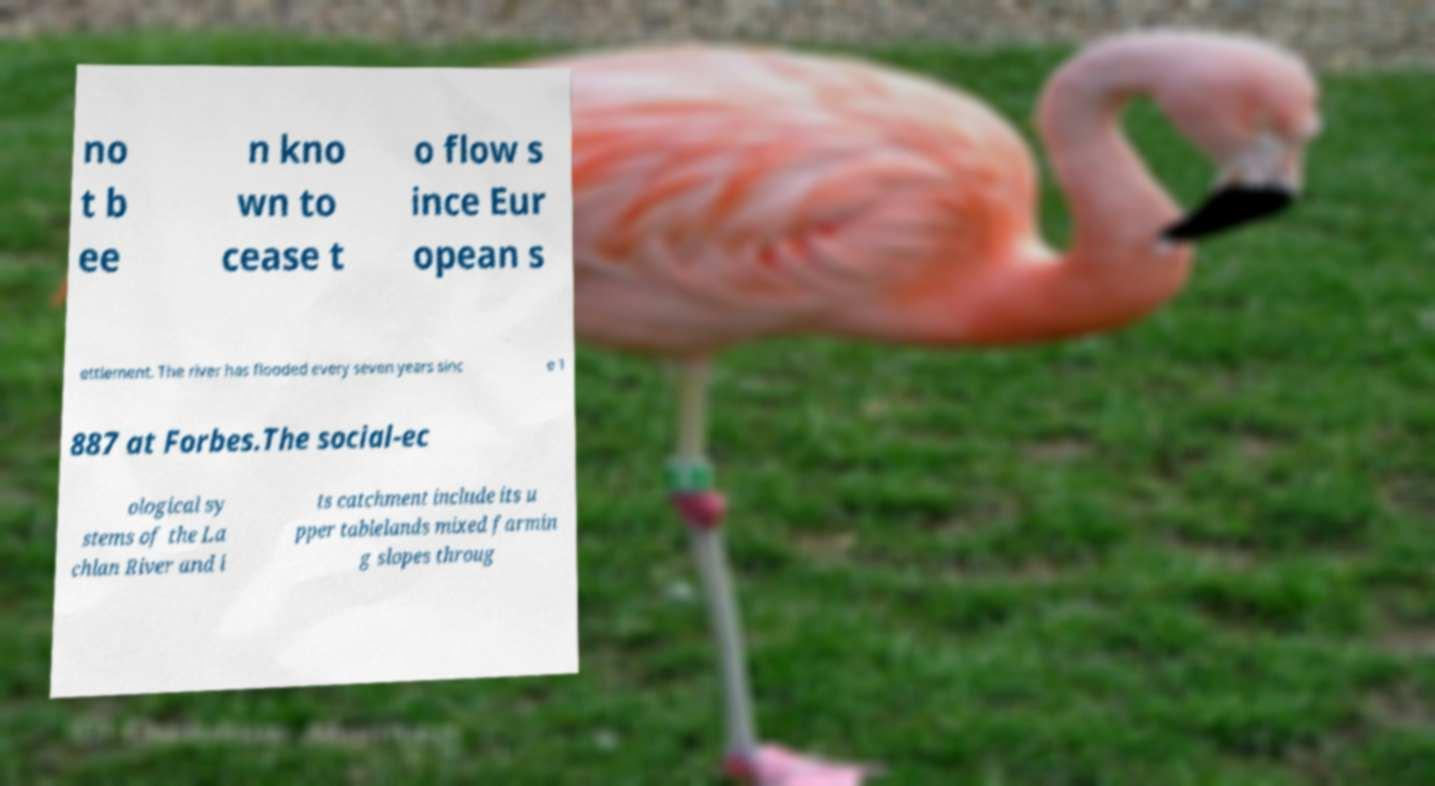For documentation purposes, I need the text within this image transcribed. Could you provide that? no t b ee n kno wn to cease t o flow s ince Eur opean s ettlement. The river has flooded every seven years sinc e 1 887 at Forbes.The social-ec ological sy stems of the La chlan River and i ts catchment include its u pper tablelands mixed farmin g slopes throug 